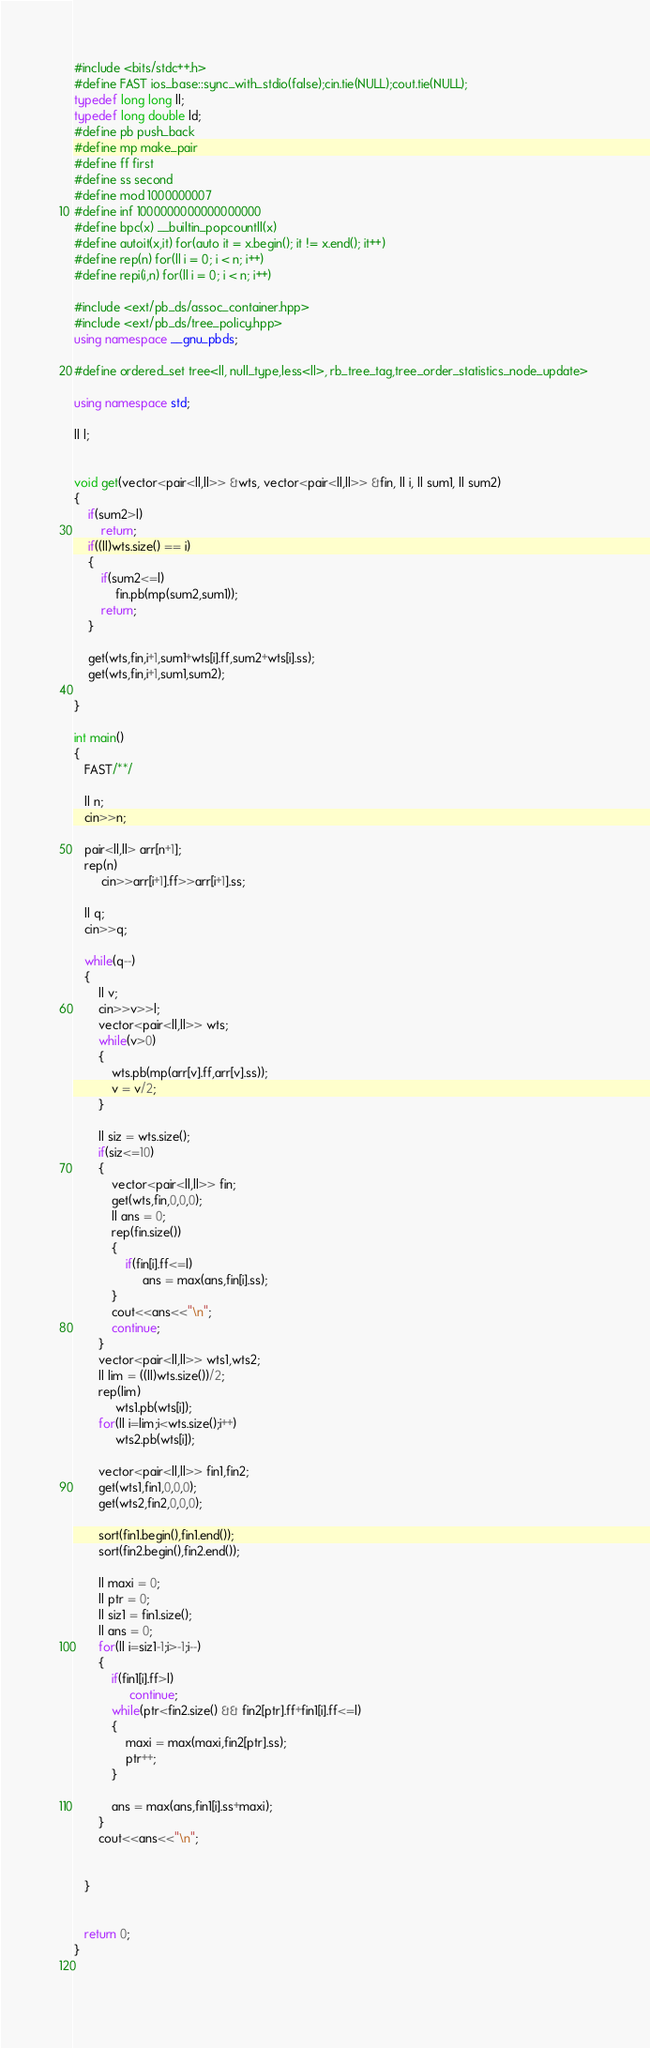Convert code to text. <code><loc_0><loc_0><loc_500><loc_500><_C++_>#include <bits/stdc++.h>
#define FAST ios_base::sync_with_stdio(false);cin.tie(NULL);cout.tie(NULL);
typedef long long ll;
typedef long double ld;
#define pb push_back
#define mp make_pair
#define ff first
#define ss second
#define mod 1000000007
#define inf 1000000000000000000
#define bpc(x) __builtin_popcountll(x)
#define autoit(x,it) for(auto it = x.begin(); it != x.end(); it++)
#define rep(n) for(ll i = 0; i < n; i++)
#define repi(i,n) for(ll i = 0; i < n; i++)

#include <ext/pb_ds/assoc_container.hpp> 
#include <ext/pb_ds/tree_policy.hpp> 
using namespace __gnu_pbds; 

#define ordered_set tree<ll, null_type,less<ll>, rb_tree_tag,tree_order_statistics_node_update> 

using namespace std;

ll l;


void get(vector<pair<ll,ll>> &wts, vector<pair<ll,ll>> &fin, ll i, ll sum1, ll sum2)
{
    if(sum2>l)
        return;
    if((ll)wts.size() == i)
    {
        if(sum2<=l)
            fin.pb(mp(sum2,sum1));
        return;
    }
    
    get(wts,fin,i+1,sum1+wts[i].ff,sum2+wts[i].ss);
    get(wts,fin,i+1,sum1,sum2);
    
}

int main()
{
   FAST/**/
   
   ll n;
   cin>>n;
   
   pair<ll,ll> arr[n+1];
   rep(n)
        cin>>arr[i+1].ff>>arr[i+1].ss;
   
   ll q;
   cin>>q;
   
   while(q--)
   {
       ll v;
       cin>>v>>l;
       vector<pair<ll,ll>> wts;
       while(v>0)
       {
           wts.pb(mp(arr[v].ff,arr[v].ss));
           v = v/2;
       }
       
       ll siz = wts.size();
       if(siz<=10)
       {
           vector<pair<ll,ll>> fin;
           get(wts,fin,0,0,0);
           ll ans = 0;
           rep(fin.size())
           {
               if(fin[i].ff<=l)
                    ans = max(ans,fin[i].ss);        
           }
           cout<<ans<<"\n";
           continue;
       }
       vector<pair<ll,ll>> wts1,wts2;
       ll lim = ((ll)wts.size())/2;
       rep(lim)
            wts1.pb(wts[i]);
       for(ll i=lim;i<wts.size();i++)
            wts2.pb(wts[i]);
       
       vector<pair<ll,ll>> fin1,fin2;
       get(wts1,fin1,0,0,0);
       get(wts2,fin2,0,0,0);
       
       sort(fin1.begin(),fin1.end());
       sort(fin2.begin(),fin2.end());
       
       ll maxi = 0;
       ll ptr = 0;
       ll siz1 = fin1.size();
       ll ans = 0;
       for(ll i=siz1-1;i>-1;i--)
       {
           if(fin1[i].ff>l)
                continue;
           while(ptr<fin2.size() && fin2[ptr].ff+fin1[i].ff<=l)
           {
               maxi = max(maxi,fin2[ptr].ss);
               ptr++;
           }
           
           ans = max(ans,fin1[i].ss+maxi);
       }
       cout<<ans<<"\n";
       
       
   }
   
   
   return 0;        
}  
  
   </code> 